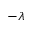Convert formula to latex. <formula><loc_0><loc_0><loc_500><loc_500>- \lambda</formula> 